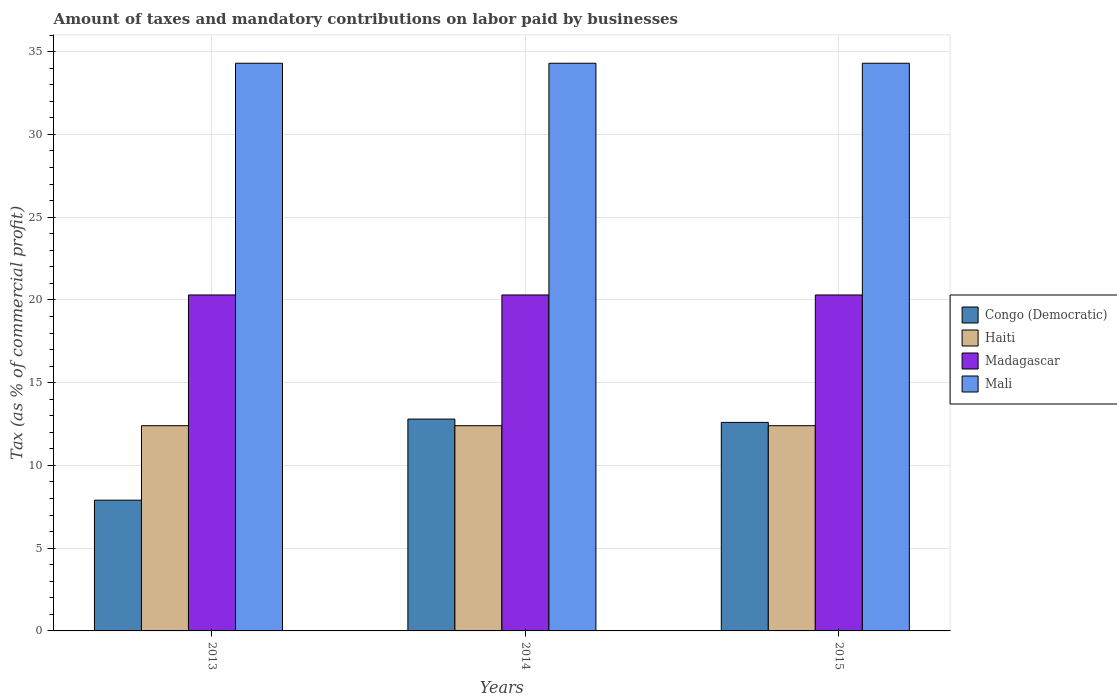How many groups of bars are there?
Provide a succinct answer. 3. Are the number of bars per tick equal to the number of legend labels?
Keep it short and to the point. Yes. Are the number of bars on each tick of the X-axis equal?
Keep it short and to the point. Yes. What is the label of the 2nd group of bars from the left?
Make the answer very short. 2014. In how many cases, is the number of bars for a given year not equal to the number of legend labels?
Your answer should be very brief. 0. What is the percentage of taxes paid by businesses in Mali in 2013?
Offer a very short reply. 34.3. Across all years, what is the maximum percentage of taxes paid by businesses in Mali?
Ensure brevity in your answer.  34.3. Across all years, what is the minimum percentage of taxes paid by businesses in Madagascar?
Provide a succinct answer. 20.3. In which year was the percentage of taxes paid by businesses in Congo (Democratic) minimum?
Your answer should be compact. 2013. What is the total percentage of taxes paid by businesses in Mali in the graph?
Keep it short and to the point. 102.9. What is the difference between the percentage of taxes paid by businesses in Congo (Democratic) in 2014 and that in 2015?
Your answer should be very brief. 0.2. What is the difference between the percentage of taxes paid by businesses in Mali in 2014 and the percentage of taxes paid by businesses in Haiti in 2013?
Provide a short and direct response. 21.9. What is the average percentage of taxes paid by businesses in Mali per year?
Your answer should be compact. 34.3. In the year 2013, what is the difference between the percentage of taxes paid by businesses in Congo (Democratic) and percentage of taxes paid by businesses in Haiti?
Your answer should be very brief. -4.5. What is the ratio of the percentage of taxes paid by businesses in Haiti in 2013 to that in 2015?
Provide a succinct answer. 1. Is the difference between the percentage of taxes paid by businesses in Congo (Democratic) in 2013 and 2015 greater than the difference between the percentage of taxes paid by businesses in Haiti in 2013 and 2015?
Your answer should be compact. No. What is the difference between the highest and the second highest percentage of taxes paid by businesses in Madagascar?
Your response must be concise. 0. What is the difference between the highest and the lowest percentage of taxes paid by businesses in Madagascar?
Provide a succinct answer. 0. Is it the case that in every year, the sum of the percentage of taxes paid by businesses in Mali and percentage of taxes paid by businesses in Congo (Democratic) is greater than the sum of percentage of taxes paid by businesses in Madagascar and percentage of taxes paid by businesses in Haiti?
Your answer should be very brief. Yes. What does the 2nd bar from the left in 2013 represents?
Give a very brief answer. Haiti. What does the 2nd bar from the right in 2013 represents?
Ensure brevity in your answer.  Madagascar. Are all the bars in the graph horizontal?
Make the answer very short. No. Does the graph contain grids?
Your answer should be compact. Yes. Where does the legend appear in the graph?
Your response must be concise. Center right. How many legend labels are there?
Offer a very short reply. 4. How are the legend labels stacked?
Offer a very short reply. Vertical. What is the title of the graph?
Make the answer very short. Amount of taxes and mandatory contributions on labor paid by businesses. Does "Japan" appear as one of the legend labels in the graph?
Your answer should be very brief. No. What is the label or title of the X-axis?
Give a very brief answer. Years. What is the label or title of the Y-axis?
Provide a succinct answer. Tax (as % of commercial profit). What is the Tax (as % of commercial profit) of Haiti in 2013?
Keep it short and to the point. 12.4. What is the Tax (as % of commercial profit) of Madagascar in 2013?
Provide a succinct answer. 20.3. What is the Tax (as % of commercial profit) in Mali in 2013?
Ensure brevity in your answer.  34.3. What is the Tax (as % of commercial profit) in Haiti in 2014?
Provide a succinct answer. 12.4. What is the Tax (as % of commercial profit) of Madagascar in 2014?
Ensure brevity in your answer.  20.3. What is the Tax (as % of commercial profit) in Mali in 2014?
Your response must be concise. 34.3. What is the Tax (as % of commercial profit) in Congo (Democratic) in 2015?
Ensure brevity in your answer.  12.6. What is the Tax (as % of commercial profit) of Madagascar in 2015?
Ensure brevity in your answer.  20.3. What is the Tax (as % of commercial profit) in Mali in 2015?
Provide a succinct answer. 34.3. Across all years, what is the maximum Tax (as % of commercial profit) in Madagascar?
Offer a very short reply. 20.3. Across all years, what is the maximum Tax (as % of commercial profit) of Mali?
Offer a terse response. 34.3. Across all years, what is the minimum Tax (as % of commercial profit) of Haiti?
Make the answer very short. 12.4. Across all years, what is the minimum Tax (as % of commercial profit) of Madagascar?
Offer a terse response. 20.3. Across all years, what is the minimum Tax (as % of commercial profit) of Mali?
Provide a succinct answer. 34.3. What is the total Tax (as % of commercial profit) in Congo (Democratic) in the graph?
Your answer should be very brief. 33.3. What is the total Tax (as % of commercial profit) of Haiti in the graph?
Your answer should be compact. 37.2. What is the total Tax (as % of commercial profit) in Madagascar in the graph?
Keep it short and to the point. 60.9. What is the total Tax (as % of commercial profit) in Mali in the graph?
Keep it short and to the point. 102.9. What is the difference between the Tax (as % of commercial profit) of Mali in 2013 and that in 2014?
Offer a very short reply. 0. What is the difference between the Tax (as % of commercial profit) in Congo (Democratic) in 2013 and that in 2015?
Make the answer very short. -4.7. What is the difference between the Tax (as % of commercial profit) in Madagascar in 2013 and that in 2015?
Offer a very short reply. 0. What is the difference between the Tax (as % of commercial profit) in Mali in 2013 and that in 2015?
Your answer should be very brief. 0. What is the difference between the Tax (as % of commercial profit) in Madagascar in 2014 and that in 2015?
Give a very brief answer. 0. What is the difference between the Tax (as % of commercial profit) of Mali in 2014 and that in 2015?
Give a very brief answer. 0. What is the difference between the Tax (as % of commercial profit) in Congo (Democratic) in 2013 and the Tax (as % of commercial profit) in Mali in 2014?
Offer a very short reply. -26.4. What is the difference between the Tax (as % of commercial profit) in Haiti in 2013 and the Tax (as % of commercial profit) in Madagascar in 2014?
Offer a terse response. -7.9. What is the difference between the Tax (as % of commercial profit) of Haiti in 2013 and the Tax (as % of commercial profit) of Mali in 2014?
Make the answer very short. -21.9. What is the difference between the Tax (as % of commercial profit) of Congo (Democratic) in 2013 and the Tax (as % of commercial profit) of Haiti in 2015?
Your answer should be very brief. -4.5. What is the difference between the Tax (as % of commercial profit) in Congo (Democratic) in 2013 and the Tax (as % of commercial profit) in Madagascar in 2015?
Keep it short and to the point. -12.4. What is the difference between the Tax (as % of commercial profit) of Congo (Democratic) in 2013 and the Tax (as % of commercial profit) of Mali in 2015?
Offer a terse response. -26.4. What is the difference between the Tax (as % of commercial profit) in Haiti in 2013 and the Tax (as % of commercial profit) in Madagascar in 2015?
Your answer should be very brief. -7.9. What is the difference between the Tax (as % of commercial profit) of Haiti in 2013 and the Tax (as % of commercial profit) of Mali in 2015?
Provide a succinct answer. -21.9. What is the difference between the Tax (as % of commercial profit) of Congo (Democratic) in 2014 and the Tax (as % of commercial profit) of Haiti in 2015?
Your answer should be compact. 0.4. What is the difference between the Tax (as % of commercial profit) in Congo (Democratic) in 2014 and the Tax (as % of commercial profit) in Madagascar in 2015?
Offer a terse response. -7.5. What is the difference between the Tax (as % of commercial profit) in Congo (Democratic) in 2014 and the Tax (as % of commercial profit) in Mali in 2015?
Make the answer very short. -21.5. What is the difference between the Tax (as % of commercial profit) in Haiti in 2014 and the Tax (as % of commercial profit) in Madagascar in 2015?
Your answer should be very brief. -7.9. What is the difference between the Tax (as % of commercial profit) of Haiti in 2014 and the Tax (as % of commercial profit) of Mali in 2015?
Provide a succinct answer. -21.9. What is the difference between the Tax (as % of commercial profit) in Madagascar in 2014 and the Tax (as % of commercial profit) in Mali in 2015?
Give a very brief answer. -14. What is the average Tax (as % of commercial profit) of Congo (Democratic) per year?
Your answer should be very brief. 11.1. What is the average Tax (as % of commercial profit) in Haiti per year?
Your answer should be very brief. 12.4. What is the average Tax (as % of commercial profit) in Madagascar per year?
Your answer should be very brief. 20.3. What is the average Tax (as % of commercial profit) of Mali per year?
Make the answer very short. 34.3. In the year 2013, what is the difference between the Tax (as % of commercial profit) in Congo (Democratic) and Tax (as % of commercial profit) in Haiti?
Your response must be concise. -4.5. In the year 2013, what is the difference between the Tax (as % of commercial profit) in Congo (Democratic) and Tax (as % of commercial profit) in Madagascar?
Your response must be concise. -12.4. In the year 2013, what is the difference between the Tax (as % of commercial profit) in Congo (Democratic) and Tax (as % of commercial profit) in Mali?
Keep it short and to the point. -26.4. In the year 2013, what is the difference between the Tax (as % of commercial profit) in Haiti and Tax (as % of commercial profit) in Madagascar?
Provide a succinct answer. -7.9. In the year 2013, what is the difference between the Tax (as % of commercial profit) of Haiti and Tax (as % of commercial profit) of Mali?
Your answer should be very brief. -21.9. In the year 2013, what is the difference between the Tax (as % of commercial profit) in Madagascar and Tax (as % of commercial profit) in Mali?
Your answer should be very brief. -14. In the year 2014, what is the difference between the Tax (as % of commercial profit) of Congo (Democratic) and Tax (as % of commercial profit) of Haiti?
Give a very brief answer. 0.4. In the year 2014, what is the difference between the Tax (as % of commercial profit) of Congo (Democratic) and Tax (as % of commercial profit) of Madagascar?
Your answer should be compact. -7.5. In the year 2014, what is the difference between the Tax (as % of commercial profit) in Congo (Democratic) and Tax (as % of commercial profit) in Mali?
Keep it short and to the point. -21.5. In the year 2014, what is the difference between the Tax (as % of commercial profit) in Haiti and Tax (as % of commercial profit) in Mali?
Offer a very short reply. -21.9. In the year 2014, what is the difference between the Tax (as % of commercial profit) of Madagascar and Tax (as % of commercial profit) of Mali?
Ensure brevity in your answer.  -14. In the year 2015, what is the difference between the Tax (as % of commercial profit) in Congo (Democratic) and Tax (as % of commercial profit) in Mali?
Ensure brevity in your answer.  -21.7. In the year 2015, what is the difference between the Tax (as % of commercial profit) of Haiti and Tax (as % of commercial profit) of Madagascar?
Provide a succinct answer. -7.9. In the year 2015, what is the difference between the Tax (as % of commercial profit) in Haiti and Tax (as % of commercial profit) in Mali?
Offer a very short reply. -21.9. In the year 2015, what is the difference between the Tax (as % of commercial profit) in Madagascar and Tax (as % of commercial profit) in Mali?
Give a very brief answer. -14. What is the ratio of the Tax (as % of commercial profit) of Congo (Democratic) in 2013 to that in 2014?
Provide a short and direct response. 0.62. What is the ratio of the Tax (as % of commercial profit) of Haiti in 2013 to that in 2014?
Your answer should be compact. 1. What is the ratio of the Tax (as % of commercial profit) of Mali in 2013 to that in 2014?
Offer a very short reply. 1. What is the ratio of the Tax (as % of commercial profit) of Congo (Democratic) in 2013 to that in 2015?
Give a very brief answer. 0.63. What is the ratio of the Tax (as % of commercial profit) of Congo (Democratic) in 2014 to that in 2015?
Keep it short and to the point. 1.02. What is the ratio of the Tax (as % of commercial profit) in Madagascar in 2014 to that in 2015?
Offer a terse response. 1. What is the difference between the highest and the second highest Tax (as % of commercial profit) in Madagascar?
Provide a succinct answer. 0. What is the difference between the highest and the lowest Tax (as % of commercial profit) in Congo (Democratic)?
Keep it short and to the point. 4.9. What is the difference between the highest and the lowest Tax (as % of commercial profit) of Mali?
Your response must be concise. 0. 